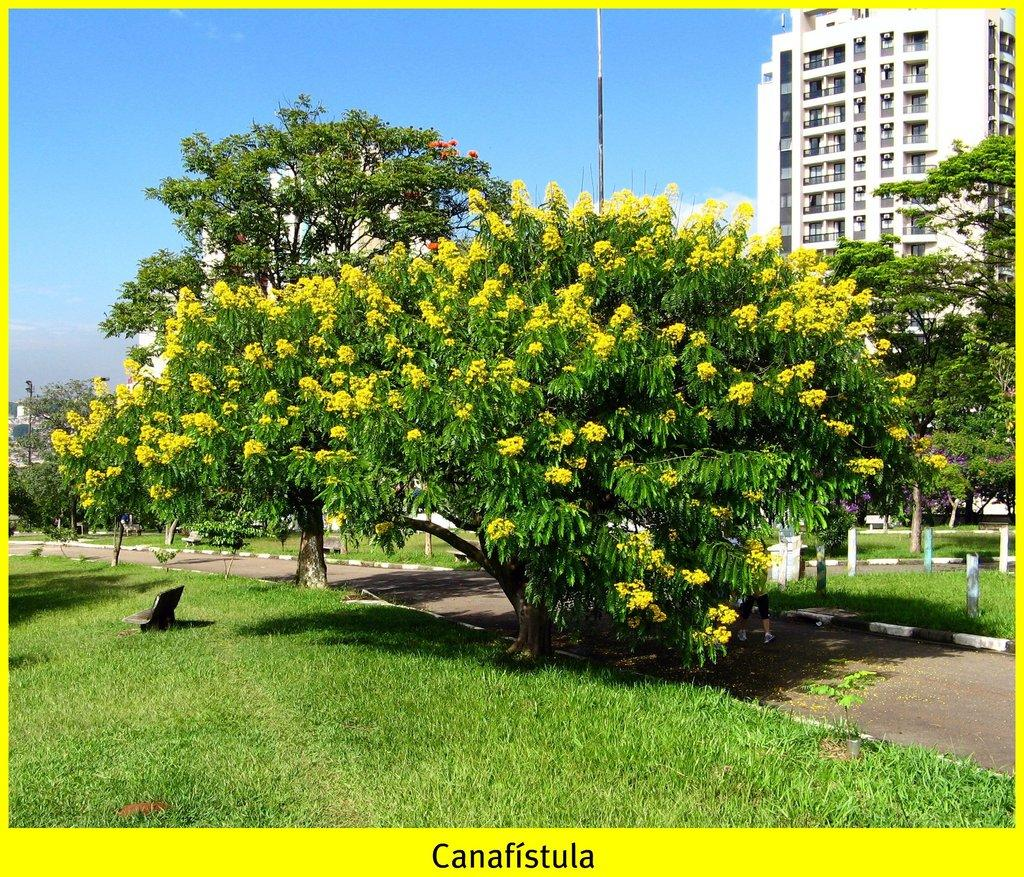What type of tree is present in the image? There is a tree with flowers in the image. What is located on the grass in the image? There is an object on the grass in the image. What can be seen in the distance in the image? There is a road, trees, poles, and buildings visible in the background of the image. What is visible in the sky in the background of the image? There are clouds in the sky in the background of the image. How many chickens are grazing on the clover in the image? There are no chickens or clover present in the image. What is the collective mind of the trees in the image? The image does not depict a collective mind of the trees; it simply shows trees with flowers and trees in the background. 